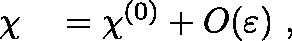<formula> <loc_0><loc_0><loc_500><loc_500>\begin{array} { r l } { \chi } & = \chi ^ { ( 0 ) } + { O } \, \left ( { \varepsilon } \right ) \, , } \end{array}</formula> 